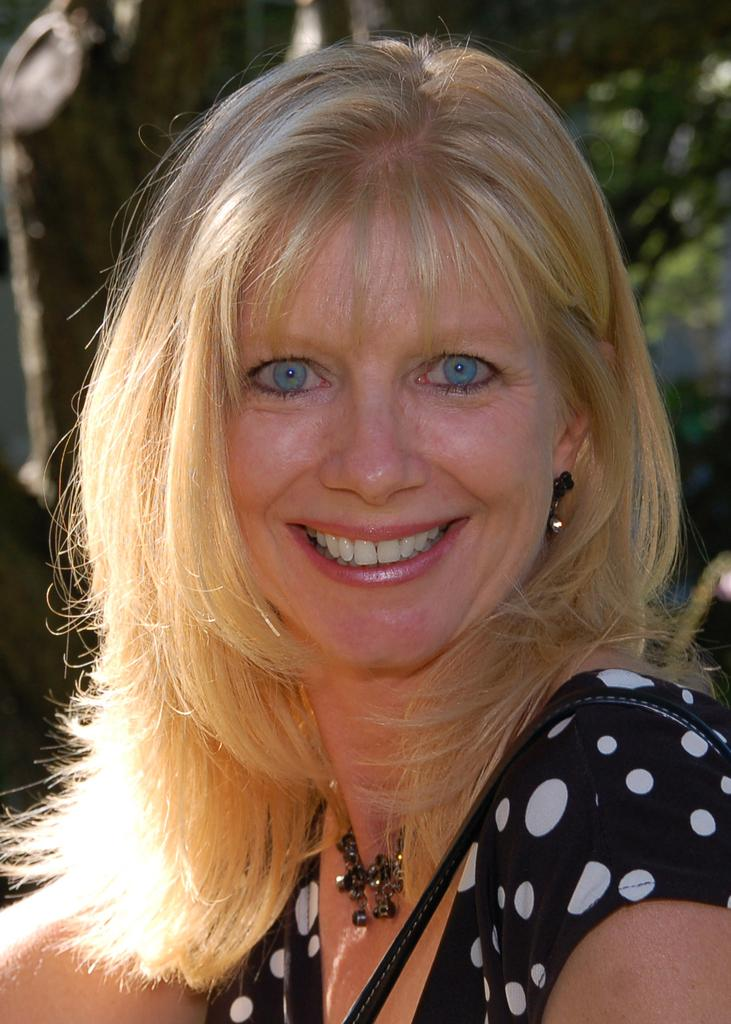Who is present in the image? There is a woman in the image. What is the woman's facial expression? The woman has a smiling face. What is the woman carrying in the image? The woman is wearing a bag. What type of natural environment is visible in the image? There are trees in the image. What can be seen in the background of the image? There are objects in the background of the image. How is the background of the image depicted? The background of the image is blurred. What type of attention does the woman require in the image? The image does not indicate that the woman requires any specific type of attention. What material is the slip made of that the woman is wearing in the image? There is no mention of a slip or any clothing other than the bag in the image. How much zinc is present in the image? There is no indication of zinc or any metallic elements in the image. 